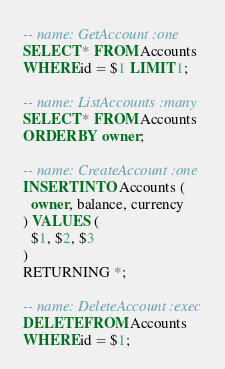Convert code to text. <code><loc_0><loc_0><loc_500><loc_500><_SQL_>-- name: GetAccount :one
SELECT * FROM Accounts
WHERE id = $1 LIMIT 1;

-- name: ListAccounts :many
SELECT * FROM Accounts
ORDER BY owner;

-- name: CreateAccount :one
INSERT INTO Accounts (
  owner, balance, currency
) VALUES (
  $1, $2, $3
)
RETURNING *;

-- name: DeleteAccount :exec
DELETE FROM Accounts
WHERE id = $1;</code> 